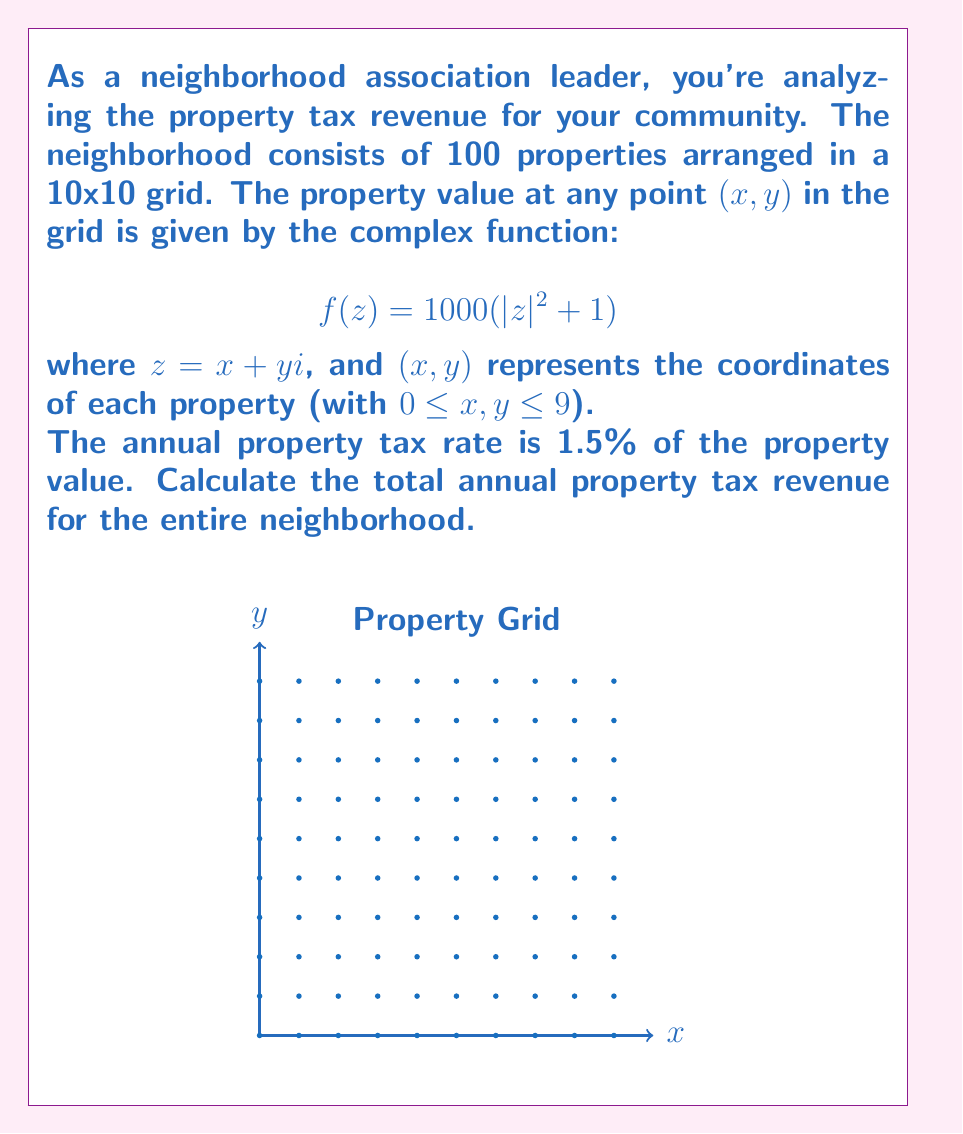Teach me how to tackle this problem. Let's approach this step-by-step:

1) First, we need to calculate the property value for each point in the grid. The property value is given by $f(z) = 1000(|z|^2 + 1)$.

2) For each point (x,y), we have $z = x + yi$. The modulus $|z|$ is given by $\sqrt{x^2 + y^2}$.

3) So, the property value at each point is:
   $$f(x,y) = 1000((x^2 + y^2) + 1)$$

4) To get the total value, we need to sum this function over all points in the grid:
   $$\text{Total Value} = \sum_{x=0}^9 \sum_{y=0}^9 1000((x^2 + y^2) + 1)$$

5) This double sum can be simplified:
   $$\text{Total Value} = 1000 \sum_{x=0}^9 \sum_{y=0}^9 (x^2 + y^2 + 1)$$

6) We can separate this into three sums:
   $$\text{Total Value} = 1000 \left(\sum_{x=0}^9 \sum_{y=0}^9 x^2 + \sum_{x=0}^9 \sum_{y=0}^9 y^2 + \sum_{x=0}^9 \sum_{y=0}^9 1\right)$$

7) The sum of squares from 0 to 9 is $\frac{9 \cdot 10 \cdot 19}{6} = 285$. So:
   $$\text{Total Value} = 1000 (10 \cdot 285 + 10 \cdot 285 + 10 \cdot 10)$$
   $$= 1000 (5700 + 5700 + 100) = 11,500,000$$

8) The annual property tax is 1.5% of this value:
   $$\text{Tax Revenue} = 0.015 \cdot 11,500,000 = 172,500$$

Therefore, the total annual property tax revenue for the neighborhood is $172,500.
Answer: $172,500 